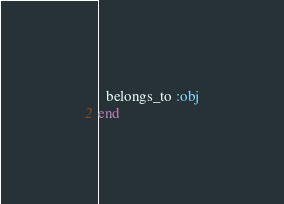<code> <loc_0><loc_0><loc_500><loc_500><_Ruby_>  belongs_to :obj
end
</code> 